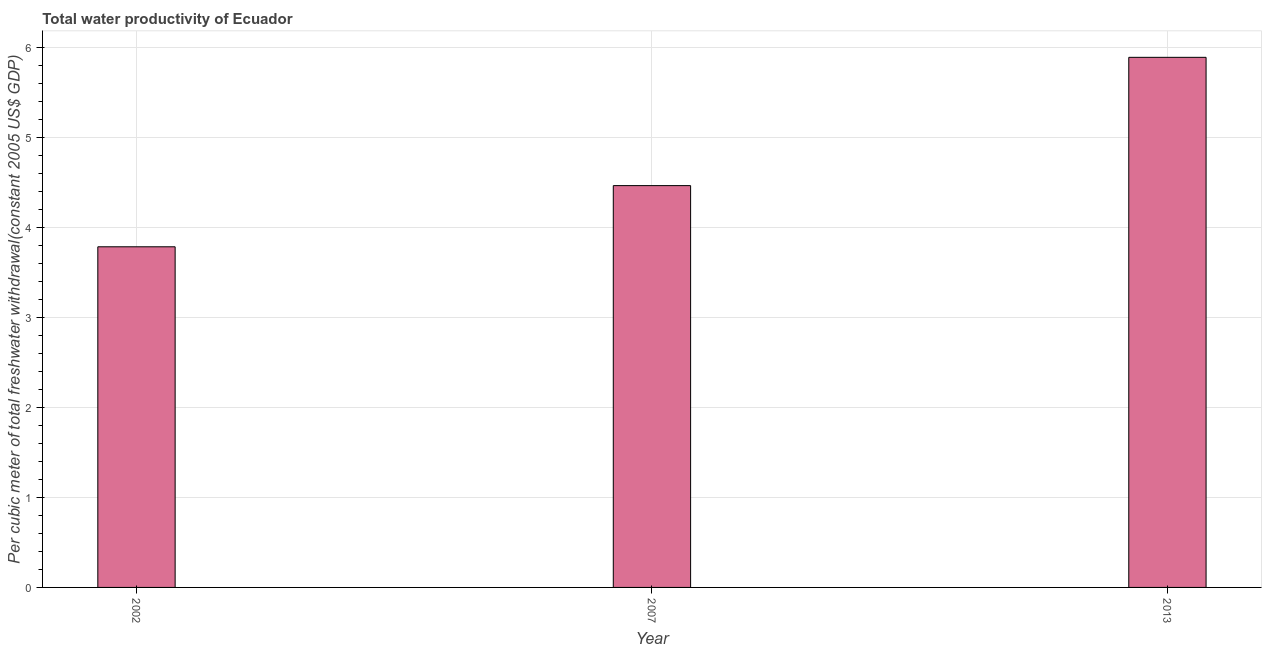Does the graph contain any zero values?
Offer a very short reply. No. What is the title of the graph?
Make the answer very short. Total water productivity of Ecuador. What is the label or title of the X-axis?
Offer a very short reply. Year. What is the label or title of the Y-axis?
Your answer should be very brief. Per cubic meter of total freshwater withdrawal(constant 2005 US$ GDP). What is the total water productivity in 2007?
Make the answer very short. 4.47. Across all years, what is the maximum total water productivity?
Your answer should be compact. 5.89. Across all years, what is the minimum total water productivity?
Make the answer very short. 3.79. In which year was the total water productivity maximum?
Offer a terse response. 2013. What is the sum of the total water productivity?
Provide a short and direct response. 14.14. What is the difference between the total water productivity in 2007 and 2013?
Your response must be concise. -1.43. What is the average total water productivity per year?
Provide a succinct answer. 4.71. What is the median total water productivity?
Provide a succinct answer. 4.47. In how many years, is the total water productivity greater than 3.4 US$?
Make the answer very short. 3. Do a majority of the years between 2007 and 2013 (inclusive) have total water productivity greater than 2 US$?
Provide a short and direct response. Yes. What is the ratio of the total water productivity in 2002 to that in 2013?
Keep it short and to the point. 0.64. Is the total water productivity in 2002 less than that in 2013?
Keep it short and to the point. Yes. What is the difference between the highest and the second highest total water productivity?
Keep it short and to the point. 1.43. Is the sum of the total water productivity in 2007 and 2013 greater than the maximum total water productivity across all years?
Provide a short and direct response. Yes. What is the difference between the highest and the lowest total water productivity?
Provide a succinct answer. 2.11. Are all the bars in the graph horizontal?
Provide a short and direct response. No. What is the difference between two consecutive major ticks on the Y-axis?
Your response must be concise. 1. Are the values on the major ticks of Y-axis written in scientific E-notation?
Make the answer very short. No. What is the Per cubic meter of total freshwater withdrawal(constant 2005 US$ GDP) in 2002?
Provide a succinct answer. 3.79. What is the Per cubic meter of total freshwater withdrawal(constant 2005 US$ GDP) of 2007?
Provide a succinct answer. 4.47. What is the Per cubic meter of total freshwater withdrawal(constant 2005 US$ GDP) in 2013?
Give a very brief answer. 5.89. What is the difference between the Per cubic meter of total freshwater withdrawal(constant 2005 US$ GDP) in 2002 and 2007?
Provide a short and direct response. -0.68. What is the difference between the Per cubic meter of total freshwater withdrawal(constant 2005 US$ GDP) in 2002 and 2013?
Your answer should be compact. -2.11. What is the difference between the Per cubic meter of total freshwater withdrawal(constant 2005 US$ GDP) in 2007 and 2013?
Keep it short and to the point. -1.43. What is the ratio of the Per cubic meter of total freshwater withdrawal(constant 2005 US$ GDP) in 2002 to that in 2007?
Your response must be concise. 0.85. What is the ratio of the Per cubic meter of total freshwater withdrawal(constant 2005 US$ GDP) in 2002 to that in 2013?
Your response must be concise. 0.64. What is the ratio of the Per cubic meter of total freshwater withdrawal(constant 2005 US$ GDP) in 2007 to that in 2013?
Keep it short and to the point. 0.76. 